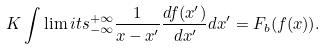<formula> <loc_0><loc_0><loc_500><loc_500>K \int \lim i t s _ { - \infty } ^ { + \infty } \frac { 1 } { x - x ^ { \prime } } \frac { d f ( x ^ { \prime } ) } { d x ^ { \prime } } d x ^ { \prime } = F _ { b } ( f ( x ) ) .</formula> 